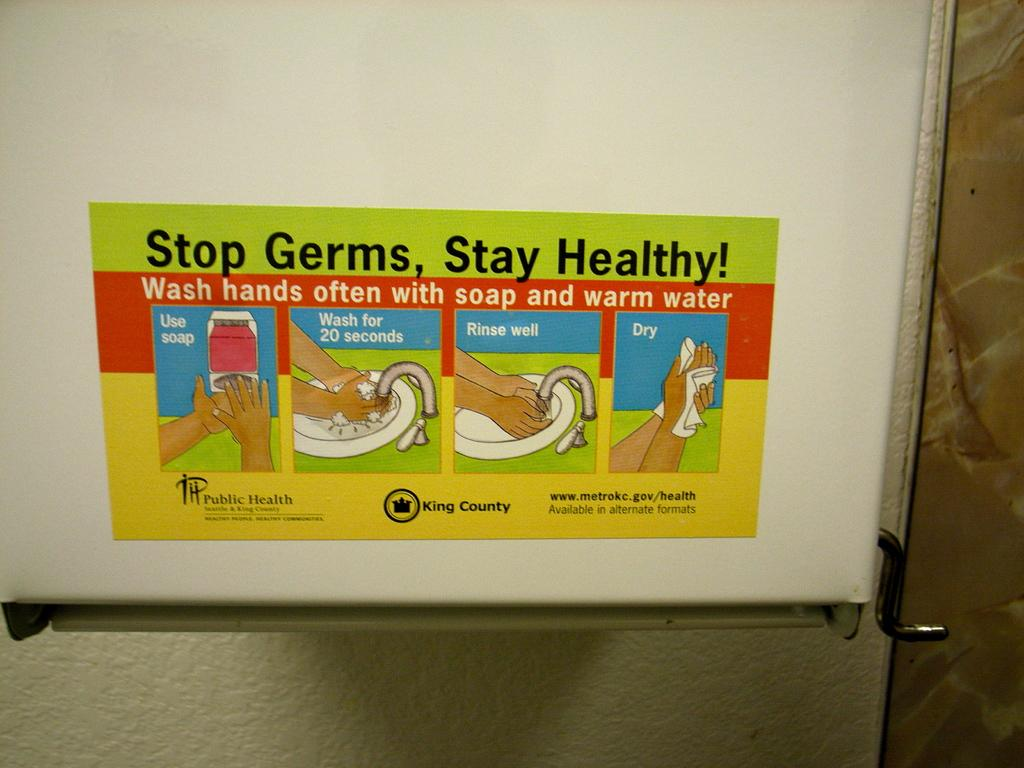<image>
Create a compact narrative representing the image presented. stop germs, stay healthy! sticker on a board 